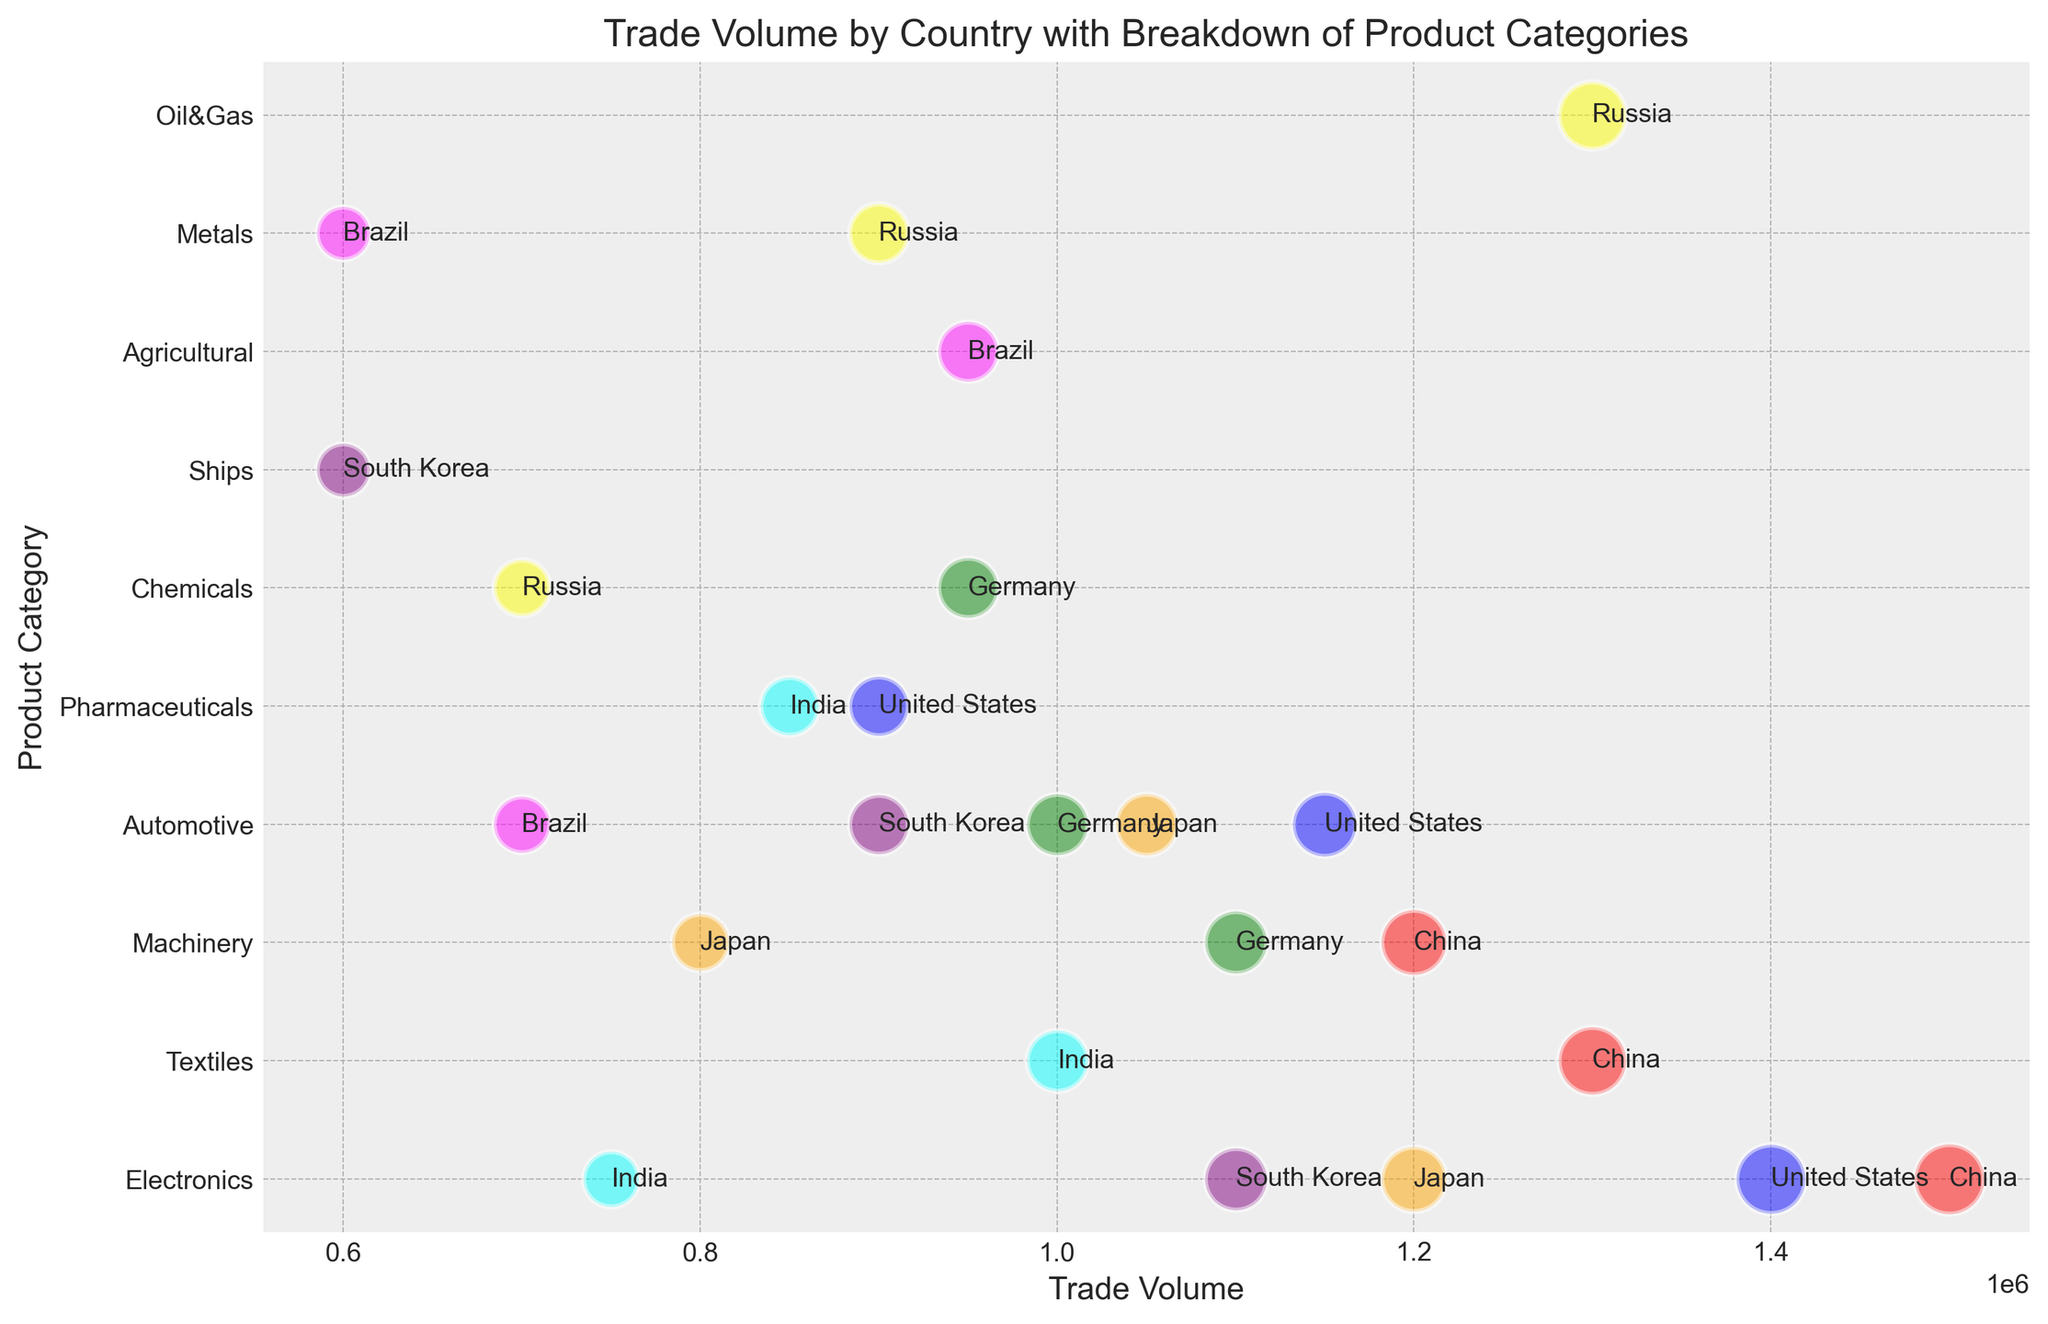Which country has the highest trade volume in Electronics? To find the country with the highest trade volume in Electronics, look at all the bubbles in the Electronics category and identify the one with the largest size. The largest bubble in the Electronics category belongs to China.
Answer: China Among the listed countries, which one has a larger trade volume in Machinery, Japan or Germany? Look at the bubbles in the Machinery category and compare the sizes of the bubbles labeled Japan and Germany. The Japanese bubble is smaller than the German bubble.
Answer: Germany Which product category has the smallest bubble size for Brazil? Look at the bubbles associated with Brazil and compare their sizes across the product categories. The smallest bubble for Brazil is in the Metals category.
Answer: Metals Compare the total trade volume for the Automotive product category between the United States and Japan. Which country has a higher trade volume? Identify the bubbles for the Automotive category and compare the bubble sizes for the United States and Japan. The United States has a bubble size of 58, and Japan has a bubble size of 54, so the United States has a higher trade volume.
Answer: United States Determine whether Russia's trade volume in Oil & Gas is higher than China's trade volume in Electronics. Compare the size of Russia's Oil & Gas bubble to China's Electronics bubble. Both bubbles have the same size of 65, so both trade volumes are equal.
Answer: Equal What's the sum of the trade volumes for Textiles across all countries? Find the bubbles in the Textiles category and sum up their trade volumes. China has 1,300,000 and India has 1,000,000, resulting in a total of 2,300,000.
Answer: 2,300,000 Which country has a greater trade volume in Pharmaceuticals, the United States or India? Locate the Pharmaceuticals bubbles for the United States and India and compare their sizes. The United States has a bubble size of 50, and India has a bubble size of 48, so the United States has a greater trade volume.
Answer: United States Is the total trade volume for Agricultural and Metals categories for Brazil higher or lower than Russia's trade volume in Metals? Sum up the trade volumes for Brazil in Agricultural (950,000) and Metals (600,000) to get 1,550,000. Compare this with Russia's trade volume in Metals (900,000). The combined volume for Brazil is higher.
Answer: Higher Which country has more representation in terms of product categories, South Korea or Germany? Count the number of distinct product categories represented by bubbles for South Korea and Germany. South Korea has Electronics, Automotive, and Ships (3 categories), while Germany has Machinery, Automotive, and Chemicals (3 categories). Both countries have equal representation.
Answer: Equal 